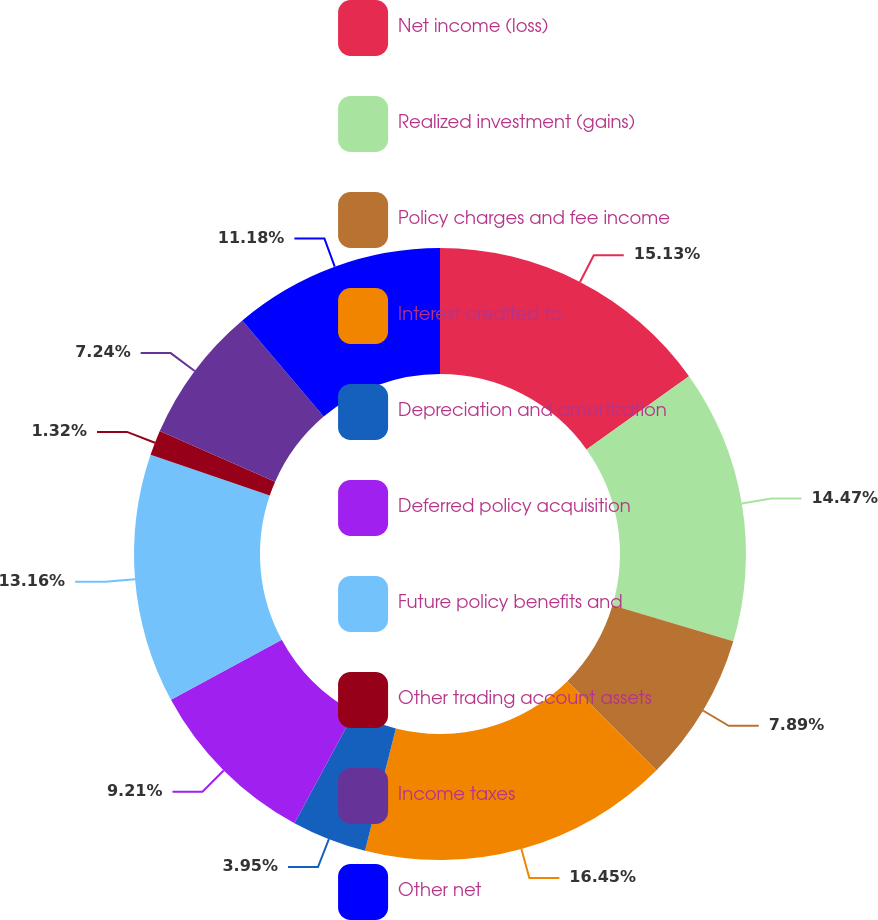Convert chart. <chart><loc_0><loc_0><loc_500><loc_500><pie_chart><fcel>Net income (loss)<fcel>Realized investment (gains)<fcel>Policy charges and fee income<fcel>Interest credited to<fcel>Depreciation and amortization<fcel>Deferred policy acquisition<fcel>Future policy benefits and<fcel>Other trading account assets<fcel>Income taxes<fcel>Other net<nl><fcel>15.13%<fcel>14.47%<fcel>7.89%<fcel>16.45%<fcel>3.95%<fcel>9.21%<fcel>13.16%<fcel>1.32%<fcel>7.24%<fcel>11.18%<nl></chart> 